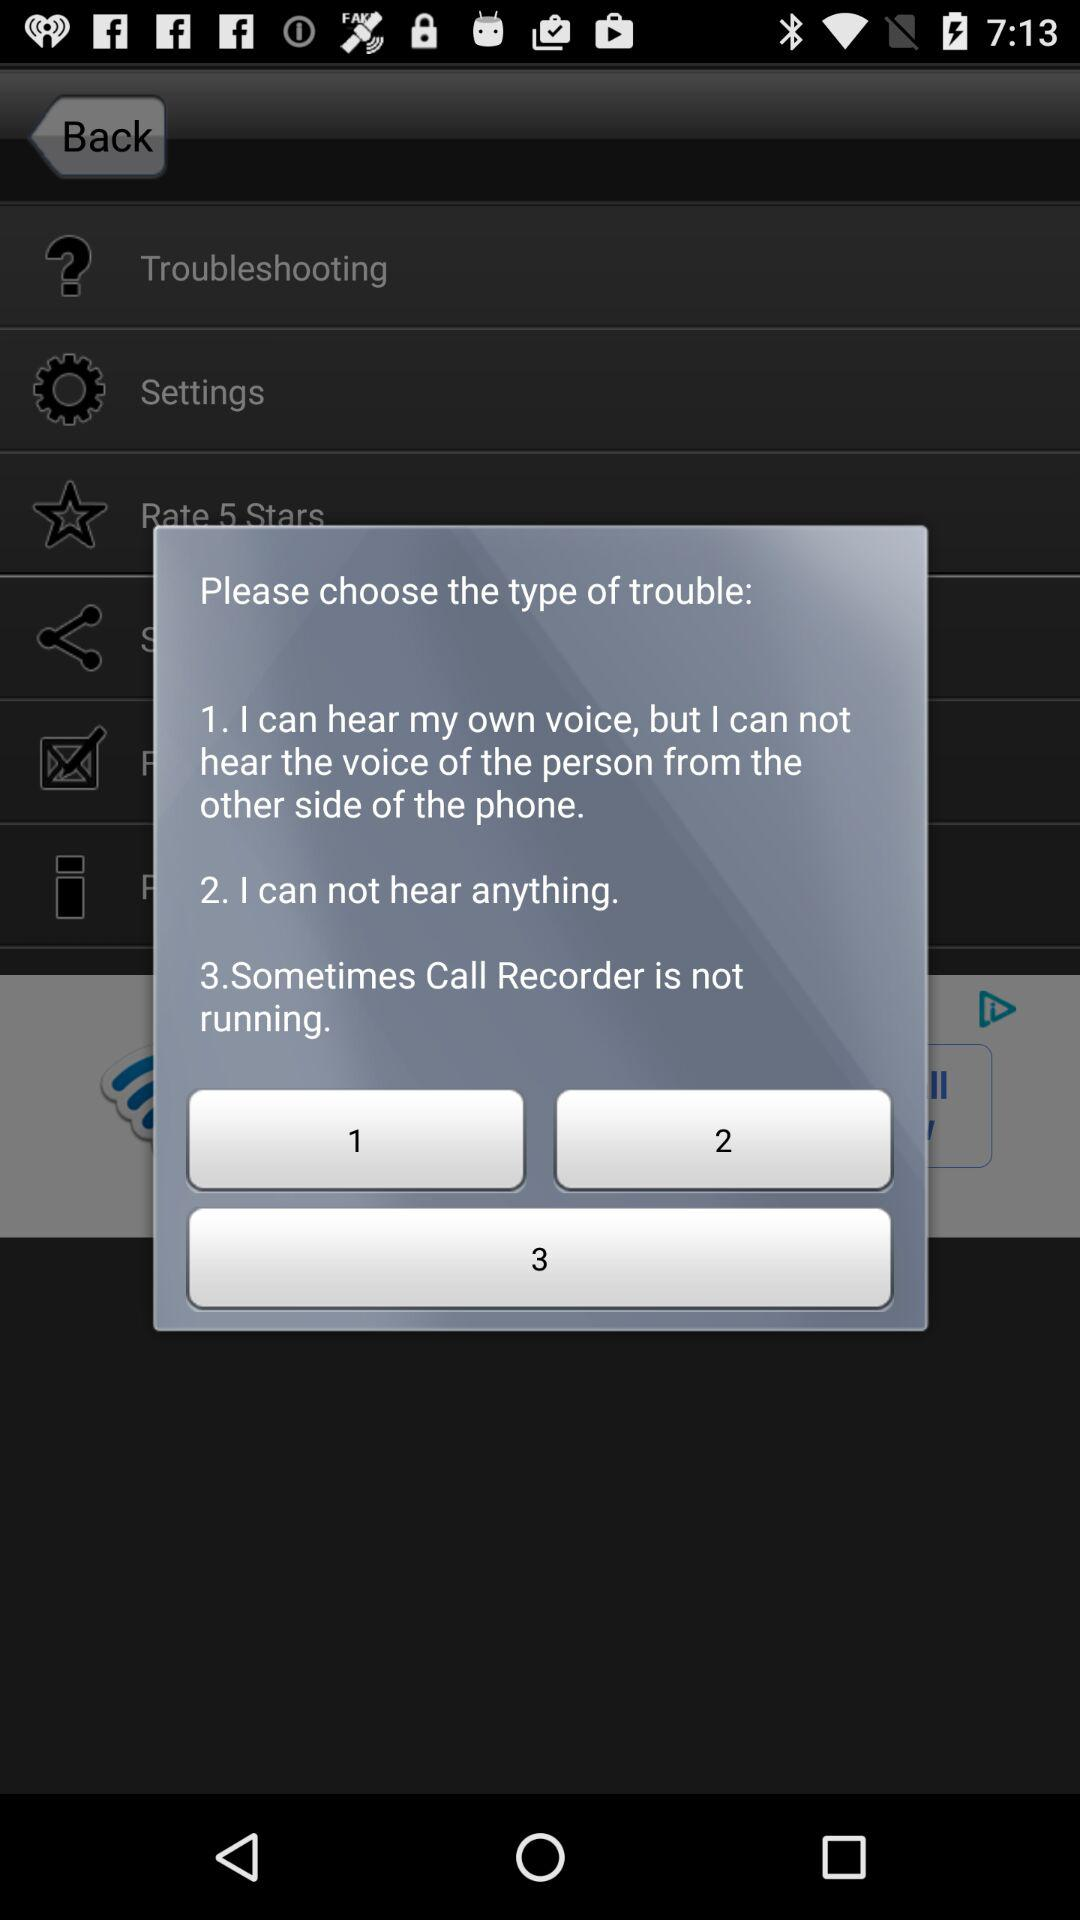How many options does the user have to choose from?
Answer the question using a single word or phrase. 3 